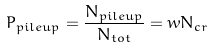Convert formula to latex. <formula><loc_0><loc_0><loc_500><loc_500>P _ { p i l e u p } = \frac { N _ { p i l e u p } } { N _ { t o t } } = w N _ { c r }</formula> 